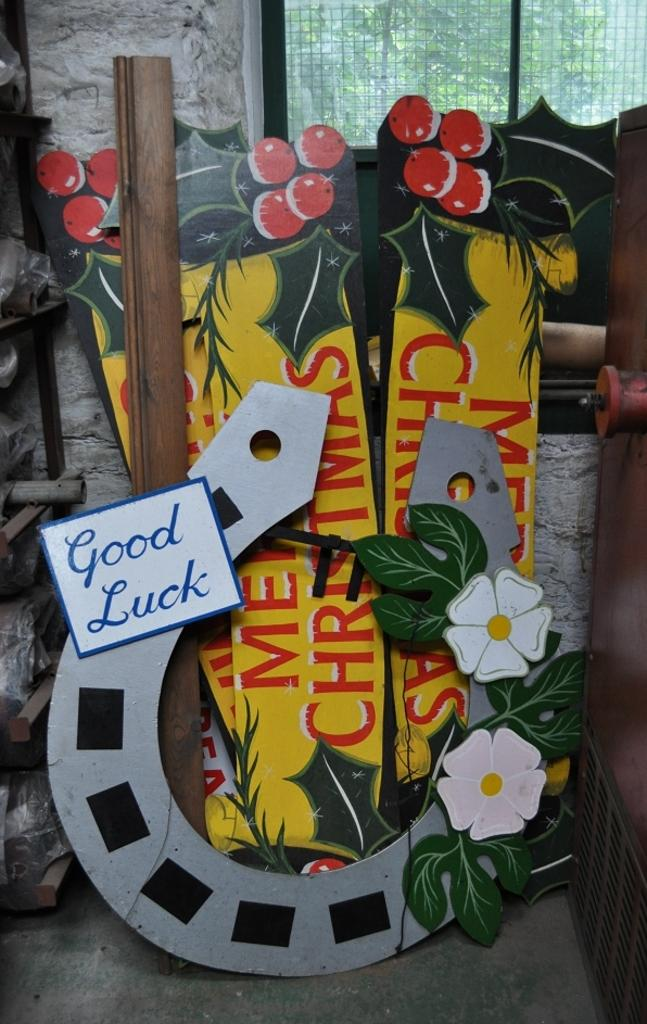What is written on the boards in the image? The facts do not specify the text on the boards, so we cannot answer that question definitively. What can be seen through the glass window in the image? Trees are visible through the glass window in the image. What is the purpose of the shelf in the image? The shelf in the image is likely used for storage or displaying items, but the facts do not specify its exact purpose. What type of articles are present in the image? The facts do not specify the type of articles present, so we cannot answer that question definitively. How many sticks are being gripped by the person in the image? There is no person present in the image, so we cannot answer that question. 